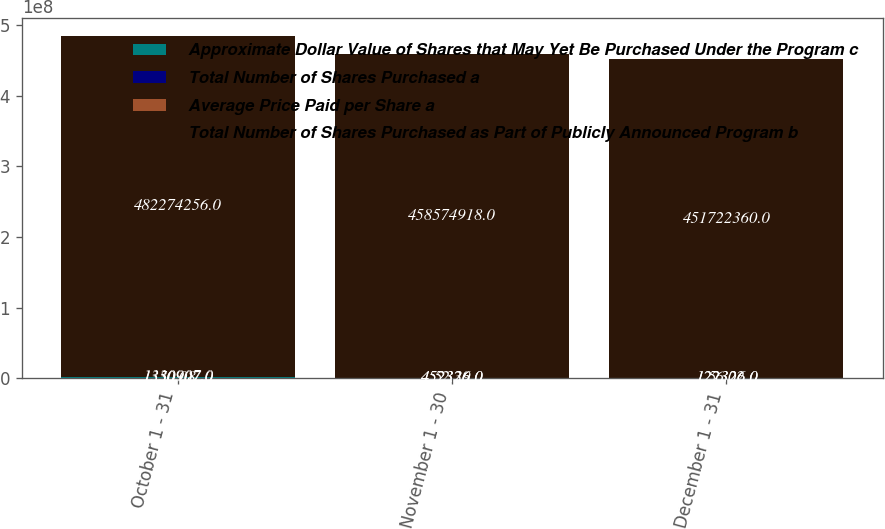Convert chart to OTSL. <chart><loc_0><loc_0><loc_500><loc_500><stacked_bar_chart><ecel><fcel>October 1 - 31<fcel>November 1 - 30<fcel>December 1 - 31<nl><fcel>Approximate Dollar Value of Shares that May Yet Be Purchased Under the Program c<fcel>1.33091e+06<fcel>452326<fcel>122326<nl><fcel>Total Number of Shares Purchased a<fcel>50.08<fcel>52.39<fcel>56.02<nl><fcel>Average Price Paid per Share a<fcel>1.33091e+06<fcel>452326<fcel>122326<nl><fcel>Total Number of Shares Purchased as Part of Publicly Announced Program b<fcel>4.82274e+08<fcel>4.58575e+08<fcel>4.51722e+08<nl></chart> 